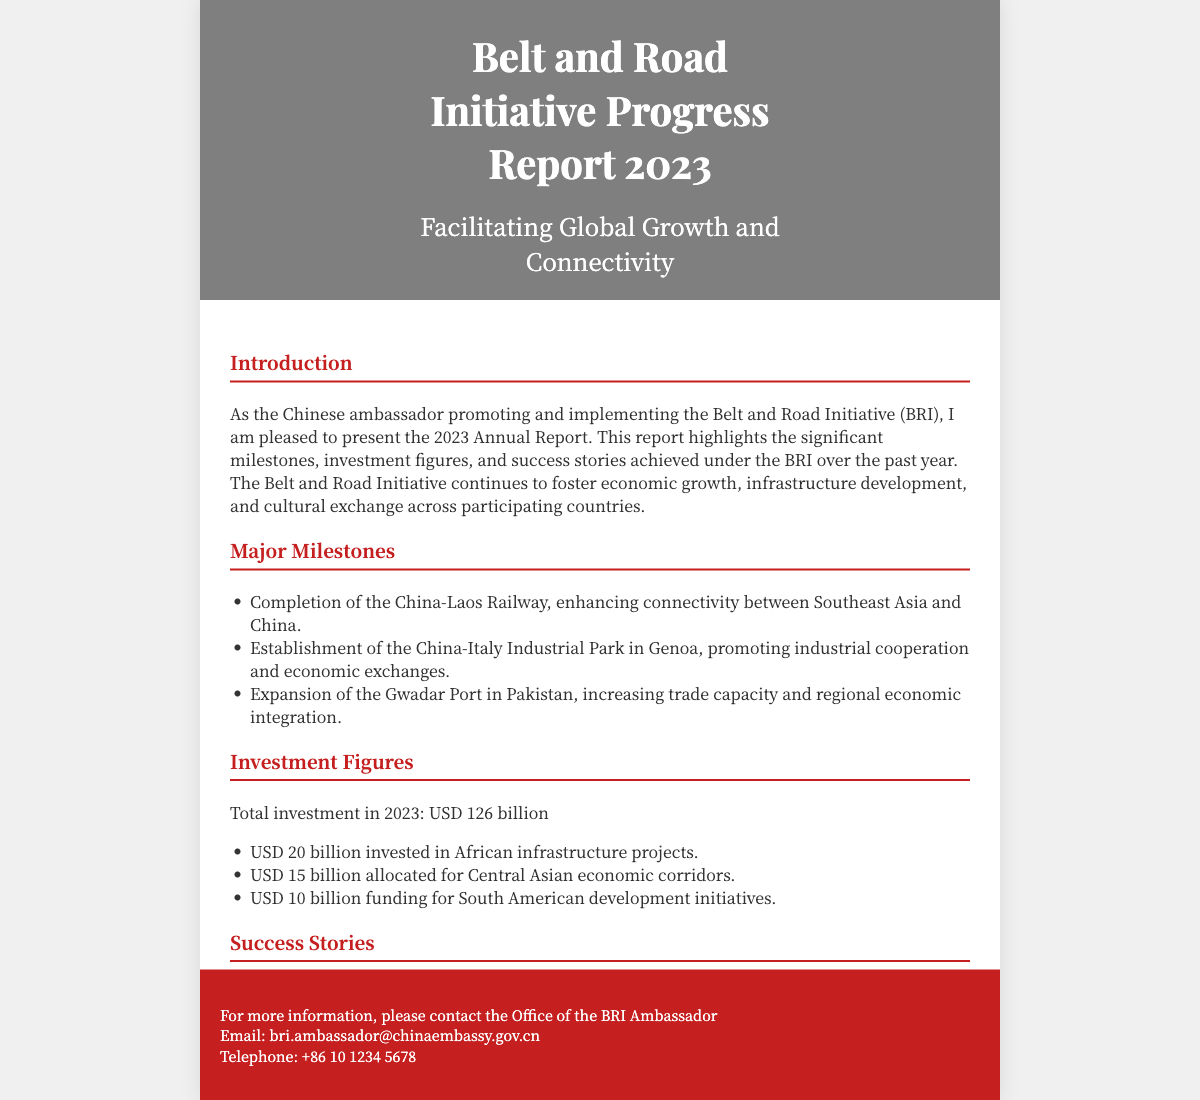What is the total investment in 2023? The total investment figure is stated clearly in the document, which is USD 126 billion.
Answer: USD 126 billion What infrastructure project was completed in 2023? The document lists several major milestones, one being the completion of the China-Laos Railway.
Answer: China-Laos Railway How much was invested in African infrastructure projects? The specific investment figure for African projects is mentioned in the document as USD 20 billion.
Answer: USD 20 billion What success story is highlighted in Kenya? The document provides a specific success story related to Kenya, which is the Nairobi-Mombasa Standard Gauge Railway.
Answer: Nairobi-Mombasa Standard Gauge Railway Which port in Greece was developed under the initiative? The document mentions the development of the Piraeus Port in Greece as a success story.
Answer: Piraeus Port What does the BRI aim to foster according to the introduction? The goals mentioned in the introduction include fostering economic growth, infrastructure development, and cultural exchange.
Answer: Economic growth, infrastructure development, and cultural exchange How much was allocated for South American development initiatives? The document specifically allocates USD 10 billion for development initiatives in South America.
Answer: USD 10 billion Which industry is promoted by the China-Italy Industrial Park? The document specifies that the China-Italy Industrial Park promotes industrial cooperation and economic exchanges.
Answer: Industrial cooperation and economic exchanges What email contact is provided for more information? The document lists an email for further inquiries, which is bri.ambassador@chinaembassy.gov.cn.
Answer: bri.ambassador@chinaembassy.gov.cn 